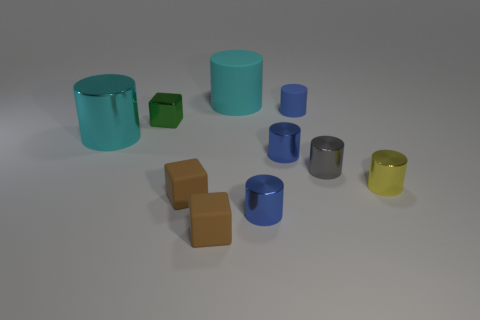The metallic cylinder on the right side of the gray cylinder is what color?
Provide a short and direct response. Yellow. How many brown things are either small matte objects or cylinders?
Make the answer very short. 2. The tiny metallic block has what color?
Ensure brevity in your answer.  Green. Are there fewer brown cubes in front of the big cyan rubber thing than tiny metal objects in front of the large cyan shiny object?
Provide a short and direct response. Yes. There is a matte object that is behind the cyan metallic thing and in front of the large matte cylinder; what shape is it?
Your response must be concise. Cylinder. What number of large cyan matte things are the same shape as the gray thing?
Provide a short and direct response. 1. There is a yellow object that is made of the same material as the gray cylinder; what is its size?
Provide a short and direct response. Small. How many gray metal things are the same size as the green thing?
Your response must be concise. 1. There is another cylinder that is the same color as the big rubber cylinder; what size is it?
Give a very brief answer. Large. The matte cylinder behind the rubber object to the right of the cyan rubber cylinder is what color?
Offer a very short reply. Cyan. 